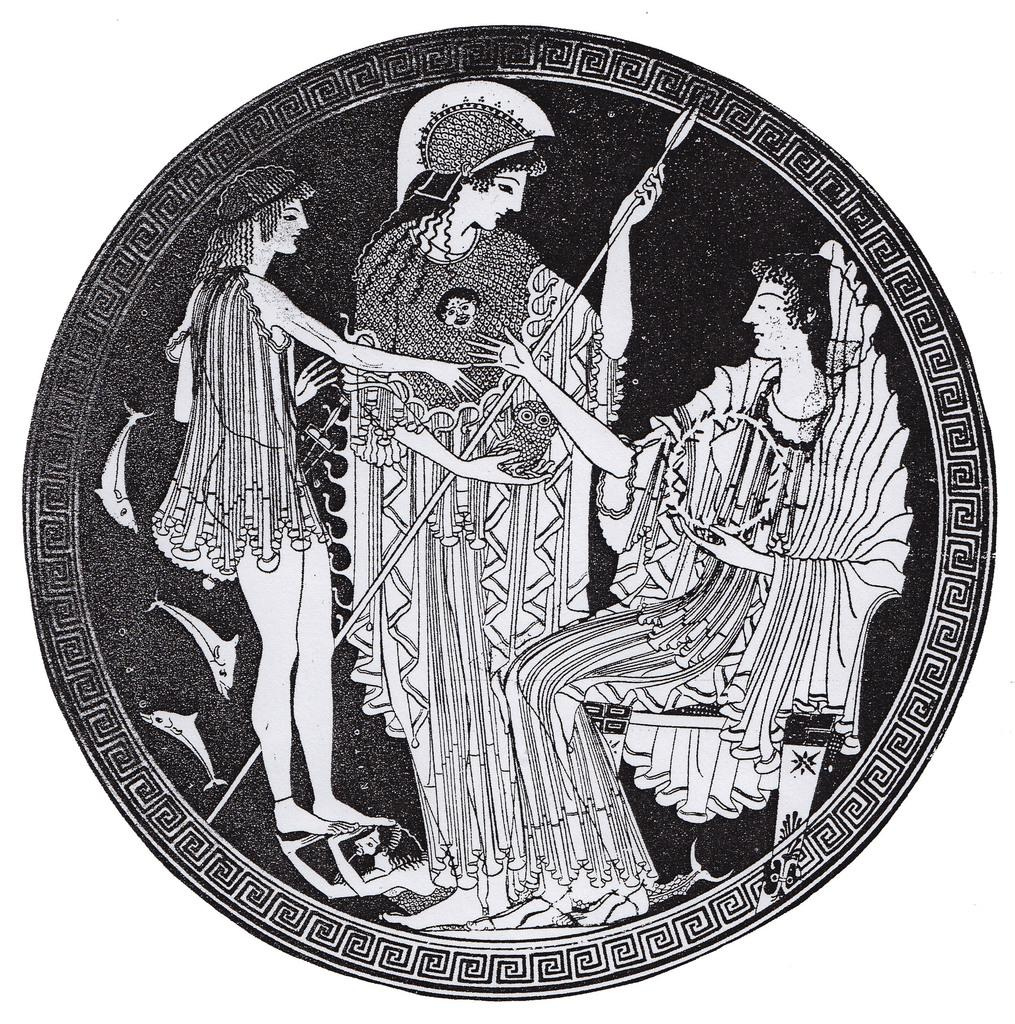What is depicted in the sketch? There are people in the sketch. What is one of the people holding? One of the people is holding an arrow. What other elements can be seen in the sketch? There are fishes in the sketch. What type of garden can be seen in the sketch? There is no garden present in the sketch. What is the limit of the arrow in the sketch? The sketch does not provide information about the limit of the arrow. 